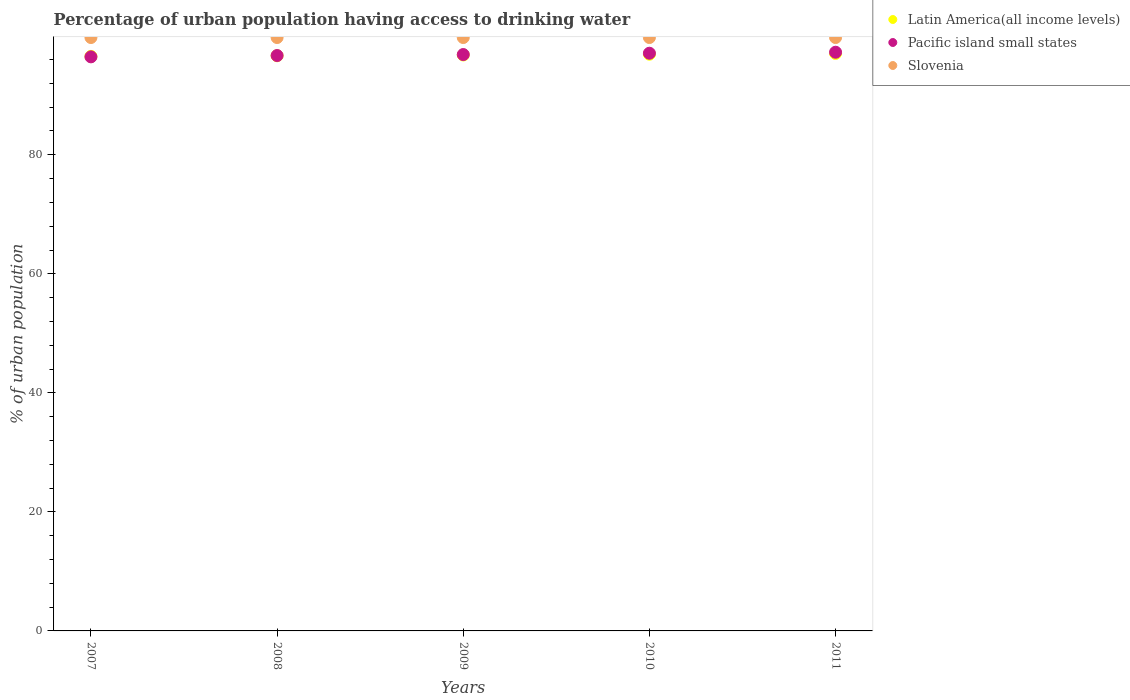How many different coloured dotlines are there?
Your response must be concise. 3. Is the number of dotlines equal to the number of legend labels?
Your answer should be compact. Yes. What is the percentage of urban population having access to drinking water in Slovenia in 2009?
Your answer should be compact. 99.7. Across all years, what is the maximum percentage of urban population having access to drinking water in Pacific island small states?
Make the answer very short. 97.23. Across all years, what is the minimum percentage of urban population having access to drinking water in Pacific island small states?
Offer a terse response. 96.45. In which year was the percentage of urban population having access to drinking water in Pacific island small states maximum?
Ensure brevity in your answer.  2011. What is the total percentage of urban population having access to drinking water in Pacific island small states in the graph?
Offer a terse response. 484.27. What is the difference between the percentage of urban population having access to drinking water in Pacific island small states in 2009 and that in 2010?
Provide a short and direct response. -0.22. What is the difference between the percentage of urban population having access to drinking water in Pacific island small states in 2010 and the percentage of urban population having access to drinking water in Slovenia in 2007?
Offer a very short reply. -2.63. What is the average percentage of urban population having access to drinking water in Slovenia per year?
Your response must be concise. 99.7. In the year 2007, what is the difference between the percentage of urban population having access to drinking water in Slovenia and percentage of urban population having access to drinking water in Pacific island small states?
Your response must be concise. 3.25. What is the ratio of the percentage of urban population having access to drinking water in Latin America(all income levels) in 2009 to that in 2011?
Keep it short and to the point. 1. Is the difference between the percentage of urban population having access to drinking water in Slovenia in 2008 and 2009 greater than the difference between the percentage of urban population having access to drinking water in Pacific island small states in 2008 and 2009?
Make the answer very short. Yes. What is the difference between the highest and the lowest percentage of urban population having access to drinking water in Pacific island small states?
Provide a succinct answer. 0.78. Is it the case that in every year, the sum of the percentage of urban population having access to drinking water in Slovenia and percentage of urban population having access to drinking water in Latin America(all income levels)  is greater than the percentage of urban population having access to drinking water in Pacific island small states?
Your answer should be very brief. Yes. Is the percentage of urban population having access to drinking water in Pacific island small states strictly greater than the percentage of urban population having access to drinking water in Slovenia over the years?
Provide a succinct answer. No. Is the percentage of urban population having access to drinking water in Pacific island small states strictly less than the percentage of urban population having access to drinking water in Latin America(all income levels) over the years?
Ensure brevity in your answer.  No. How many years are there in the graph?
Your answer should be compact. 5. What is the difference between two consecutive major ticks on the Y-axis?
Keep it short and to the point. 20. Are the values on the major ticks of Y-axis written in scientific E-notation?
Provide a short and direct response. No. Does the graph contain any zero values?
Ensure brevity in your answer.  No. Does the graph contain grids?
Keep it short and to the point. No. Where does the legend appear in the graph?
Give a very brief answer. Top right. How are the legend labels stacked?
Provide a short and direct response. Vertical. What is the title of the graph?
Offer a terse response. Percentage of urban population having access to drinking water. Does "Costa Rica" appear as one of the legend labels in the graph?
Keep it short and to the point. No. What is the label or title of the Y-axis?
Give a very brief answer. % of urban population. What is the % of urban population in Latin America(all income levels) in 2007?
Give a very brief answer. 96.54. What is the % of urban population in Pacific island small states in 2007?
Offer a terse response. 96.45. What is the % of urban population in Slovenia in 2007?
Your answer should be compact. 99.7. What is the % of urban population of Latin America(all income levels) in 2008?
Offer a terse response. 96.64. What is the % of urban population of Pacific island small states in 2008?
Provide a short and direct response. 96.68. What is the % of urban population of Slovenia in 2008?
Give a very brief answer. 99.7. What is the % of urban population in Latin America(all income levels) in 2009?
Your response must be concise. 96.77. What is the % of urban population of Pacific island small states in 2009?
Make the answer very short. 96.84. What is the % of urban population of Slovenia in 2009?
Offer a very short reply. 99.7. What is the % of urban population of Latin America(all income levels) in 2010?
Offer a terse response. 96.9. What is the % of urban population in Pacific island small states in 2010?
Offer a very short reply. 97.07. What is the % of urban population of Slovenia in 2010?
Ensure brevity in your answer.  99.7. What is the % of urban population in Latin America(all income levels) in 2011?
Provide a short and direct response. 97.03. What is the % of urban population in Pacific island small states in 2011?
Make the answer very short. 97.23. What is the % of urban population of Slovenia in 2011?
Offer a very short reply. 99.7. Across all years, what is the maximum % of urban population in Latin America(all income levels)?
Your answer should be compact. 97.03. Across all years, what is the maximum % of urban population of Pacific island small states?
Your answer should be very brief. 97.23. Across all years, what is the maximum % of urban population of Slovenia?
Give a very brief answer. 99.7. Across all years, what is the minimum % of urban population of Latin America(all income levels)?
Make the answer very short. 96.54. Across all years, what is the minimum % of urban population in Pacific island small states?
Your answer should be compact. 96.45. Across all years, what is the minimum % of urban population of Slovenia?
Keep it short and to the point. 99.7. What is the total % of urban population of Latin America(all income levels) in the graph?
Your answer should be compact. 483.87. What is the total % of urban population of Pacific island small states in the graph?
Your response must be concise. 484.27. What is the total % of urban population in Slovenia in the graph?
Keep it short and to the point. 498.5. What is the difference between the % of urban population in Latin America(all income levels) in 2007 and that in 2008?
Your answer should be very brief. -0.1. What is the difference between the % of urban population of Pacific island small states in 2007 and that in 2008?
Give a very brief answer. -0.22. What is the difference between the % of urban population in Latin America(all income levels) in 2007 and that in 2009?
Provide a short and direct response. -0.23. What is the difference between the % of urban population in Pacific island small states in 2007 and that in 2009?
Your answer should be very brief. -0.39. What is the difference between the % of urban population in Latin America(all income levels) in 2007 and that in 2010?
Ensure brevity in your answer.  -0.36. What is the difference between the % of urban population of Pacific island small states in 2007 and that in 2010?
Your response must be concise. -0.61. What is the difference between the % of urban population of Slovenia in 2007 and that in 2010?
Offer a very short reply. 0. What is the difference between the % of urban population of Latin America(all income levels) in 2007 and that in 2011?
Make the answer very short. -0.49. What is the difference between the % of urban population of Pacific island small states in 2007 and that in 2011?
Offer a very short reply. -0.78. What is the difference between the % of urban population of Latin America(all income levels) in 2008 and that in 2009?
Make the answer very short. -0.13. What is the difference between the % of urban population of Pacific island small states in 2008 and that in 2009?
Give a very brief answer. -0.16. What is the difference between the % of urban population of Latin America(all income levels) in 2008 and that in 2010?
Your answer should be very brief. -0.26. What is the difference between the % of urban population of Pacific island small states in 2008 and that in 2010?
Your answer should be compact. -0.39. What is the difference between the % of urban population of Slovenia in 2008 and that in 2010?
Your answer should be very brief. 0. What is the difference between the % of urban population in Latin America(all income levels) in 2008 and that in 2011?
Provide a short and direct response. -0.39. What is the difference between the % of urban population of Pacific island small states in 2008 and that in 2011?
Your answer should be compact. -0.56. What is the difference between the % of urban population of Latin America(all income levels) in 2009 and that in 2010?
Your answer should be very brief. -0.13. What is the difference between the % of urban population in Pacific island small states in 2009 and that in 2010?
Give a very brief answer. -0.22. What is the difference between the % of urban population of Slovenia in 2009 and that in 2010?
Your answer should be compact. 0. What is the difference between the % of urban population of Latin America(all income levels) in 2009 and that in 2011?
Your answer should be compact. -0.26. What is the difference between the % of urban population in Pacific island small states in 2009 and that in 2011?
Your answer should be compact. -0.39. What is the difference between the % of urban population in Latin America(all income levels) in 2010 and that in 2011?
Your response must be concise. -0.13. What is the difference between the % of urban population in Pacific island small states in 2010 and that in 2011?
Your answer should be compact. -0.17. What is the difference between the % of urban population of Slovenia in 2010 and that in 2011?
Your answer should be compact. 0. What is the difference between the % of urban population of Latin America(all income levels) in 2007 and the % of urban population of Pacific island small states in 2008?
Keep it short and to the point. -0.14. What is the difference between the % of urban population of Latin America(all income levels) in 2007 and the % of urban population of Slovenia in 2008?
Your answer should be very brief. -3.16. What is the difference between the % of urban population in Pacific island small states in 2007 and the % of urban population in Slovenia in 2008?
Your answer should be very brief. -3.25. What is the difference between the % of urban population in Latin America(all income levels) in 2007 and the % of urban population in Pacific island small states in 2009?
Your response must be concise. -0.3. What is the difference between the % of urban population in Latin America(all income levels) in 2007 and the % of urban population in Slovenia in 2009?
Offer a very short reply. -3.16. What is the difference between the % of urban population in Pacific island small states in 2007 and the % of urban population in Slovenia in 2009?
Your response must be concise. -3.25. What is the difference between the % of urban population of Latin America(all income levels) in 2007 and the % of urban population of Pacific island small states in 2010?
Keep it short and to the point. -0.53. What is the difference between the % of urban population of Latin America(all income levels) in 2007 and the % of urban population of Slovenia in 2010?
Your answer should be compact. -3.16. What is the difference between the % of urban population of Pacific island small states in 2007 and the % of urban population of Slovenia in 2010?
Offer a terse response. -3.25. What is the difference between the % of urban population of Latin America(all income levels) in 2007 and the % of urban population of Pacific island small states in 2011?
Make the answer very short. -0.7. What is the difference between the % of urban population of Latin America(all income levels) in 2007 and the % of urban population of Slovenia in 2011?
Ensure brevity in your answer.  -3.16. What is the difference between the % of urban population of Pacific island small states in 2007 and the % of urban population of Slovenia in 2011?
Give a very brief answer. -3.25. What is the difference between the % of urban population of Latin America(all income levels) in 2008 and the % of urban population of Pacific island small states in 2009?
Ensure brevity in your answer.  -0.21. What is the difference between the % of urban population of Latin America(all income levels) in 2008 and the % of urban population of Slovenia in 2009?
Keep it short and to the point. -3.06. What is the difference between the % of urban population in Pacific island small states in 2008 and the % of urban population in Slovenia in 2009?
Keep it short and to the point. -3.02. What is the difference between the % of urban population of Latin America(all income levels) in 2008 and the % of urban population of Pacific island small states in 2010?
Give a very brief answer. -0.43. What is the difference between the % of urban population of Latin America(all income levels) in 2008 and the % of urban population of Slovenia in 2010?
Keep it short and to the point. -3.06. What is the difference between the % of urban population in Pacific island small states in 2008 and the % of urban population in Slovenia in 2010?
Your answer should be very brief. -3.02. What is the difference between the % of urban population of Latin America(all income levels) in 2008 and the % of urban population of Pacific island small states in 2011?
Offer a terse response. -0.6. What is the difference between the % of urban population in Latin America(all income levels) in 2008 and the % of urban population in Slovenia in 2011?
Provide a succinct answer. -3.06. What is the difference between the % of urban population of Pacific island small states in 2008 and the % of urban population of Slovenia in 2011?
Provide a short and direct response. -3.02. What is the difference between the % of urban population of Latin America(all income levels) in 2009 and the % of urban population of Pacific island small states in 2010?
Your answer should be very brief. -0.3. What is the difference between the % of urban population of Latin America(all income levels) in 2009 and the % of urban population of Slovenia in 2010?
Give a very brief answer. -2.93. What is the difference between the % of urban population in Pacific island small states in 2009 and the % of urban population in Slovenia in 2010?
Your response must be concise. -2.86. What is the difference between the % of urban population in Latin America(all income levels) in 2009 and the % of urban population in Pacific island small states in 2011?
Your response must be concise. -0.46. What is the difference between the % of urban population of Latin America(all income levels) in 2009 and the % of urban population of Slovenia in 2011?
Ensure brevity in your answer.  -2.93. What is the difference between the % of urban population in Pacific island small states in 2009 and the % of urban population in Slovenia in 2011?
Ensure brevity in your answer.  -2.86. What is the difference between the % of urban population in Latin America(all income levels) in 2010 and the % of urban population in Pacific island small states in 2011?
Your response must be concise. -0.33. What is the difference between the % of urban population of Latin America(all income levels) in 2010 and the % of urban population of Slovenia in 2011?
Make the answer very short. -2.8. What is the difference between the % of urban population of Pacific island small states in 2010 and the % of urban population of Slovenia in 2011?
Offer a terse response. -2.63. What is the average % of urban population of Latin America(all income levels) per year?
Offer a very short reply. 96.77. What is the average % of urban population in Pacific island small states per year?
Offer a terse response. 96.85. What is the average % of urban population in Slovenia per year?
Keep it short and to the point. 99.7. In the year 2007, what is the difference between the % of urban population in Latin America(all income levels) and % of urban population in Pacific island small states?
Your answer should be compact. 0.08. In the year 2007, what is the difference between the % of urban population in Latin America(all income levels) and % of urban population in Slovenia?
Make the answer very short. -3.16. In the year 2007, what is the difference between the % of urban population in Pacific island small states and % of urban population in Slovenia?
Offer a terse response. -3.25. In the year 2008, what is the difference between the % of urban population of Latin America(all income levels) and % of urban population of Pacific island small states?
Offer a very short reply. -0.04. In the year 2008, what is the difference between the % of urban population of Latin America(all income levels) and % of urban population of Slovenia?
Ensure brevity in your answer.  -3.06. In the year 2008, what is the difference between the % of urban population in Pacific island small states and % of urban population in Slovenia?
Your response must be concise. -3.02. In the year 2009, what is the difference between the % of urban population of Latin America(all income levels) and % of urban population of Pacific island small states?
Your response must be concise. -0.07. In the year 2009, what is the difference between the % of urban population in Latin America(all income levels) and % of urban population in Slovenia?
Offer a very short reply. -2.93. In the year 2009, what is the difference between the % of urban population of Pacific island small states and % of urban population of Slovenia?
Offer a very short reply. -2.86. In the year 2010, what is the difference between the % of urban population in Latin America(all income levels) and % of urban population in Pacific island small states?
Your answer should be very brief. -0.17. In the year 2010, what is the difference between the % of urban population in Latin America(all income levels) and % of urban population in Slovenia?
Make the answer very short. -2.8. In the year 2010, what is the difference between the % of urban population in Pacific island small states and % of urban population in Slovenia?
Make the answer very short. -2.63. In the year 2011, what is the difference between the % of urban population of Latin America(all income levels) and % of urban population of Pacific island small states?
Your response must be concise. -0.2. In the year 2011, what is the difference between the % of urban population in Latin America(all income levels) and % of urban population in Slovenia?
Your answer should be compact. -2.67. In the year 2011, what is the difference between the % of urban population in Pacific island small states and % of urban population in Slovenia?
Your answer should be very brief. -2.47. What is the ratio of the % of urban population of Latin America(all income levels) in 2007 to that in 2008?
Give a very brief answer. 1. What is the ratio of the % of urban population of Latin America(all income levels) in 2007 to that in 2009?
Your answer should be very brief. 1. What is the ratio of the % of urban population of Slovenia in 2007 to that in 2009?
Your response must be concise. 1. What is the ratio of the % of urban population of Latin America(all income levels) in 2007 to that in 2010?
Provide a succinct answer. 1. What is the ratio of the % of urban population of Pacific island small states in 2007 to that in 2010?
Provide a short and direct response. 0.99. What is the ratio of the % of urban population of Slovenia in 2007 to that in 2010?
Your answer should be very brief. 1. What is the ratio of the % of urban population of Latin America(all income levels) in 2007 to that in 2011?
Keep it short and to the point. 0.99. What is the ratio of the % of urban population of Pacific island small states in 2007 to that in 2011?
Offer a very short reply. 0.99. What is the ratio of the % of urban population of Pacific island small states in 2008 to that in 2011?
Provide a short and direct response. 0.99. What is the ratio of the % of urban population of Slovenia in 2008 to that in 2011?
Provide a short and direct response. 1. What is the ratio of the % of urban population of Slovenia in 2009 to that in 2010?
Make the answer very short. 1. What is the ratio of the % of urban population of Latin America(all income levels) in 2009 to that in 2011?
Your answer should be compact. 1. What is the ratio of the % of urban population of Pacific island small states in 2009 to that in 2011?
Make the answer very short. 1. What is the ratio of the % of urban population of Latin America(all income levels) in 2010 to that in 2011?
Keep it short and to the point. 1. What is the ratio of the % of urban population of Pacific island small states in 2010 to that in 2011?
Give a very brief answer. 1. What is the ratio of the % of urban population of Slovenia in 2010 to that in 2011?
Offer a terse response. 1. What is the difference between the highest and the second highest % of urban population in Latin America(all income levels)?
Keep it short and to the point. 0.13. What is the difference between the highest and the second highest % of urban population in Pacific island small states?
Your response must be concise. 0.17. What is the difference between the highest and the second highest % of urban population of Slovenia?
Give a very brief answer. 0. What is the difference between the highest and the lowest % of urban population in Latin America(all income levels)?
Your answer should be very brief. 0.49. What is the difference between the highest and the lowest % of urban population in Pacific island small states?
Your answer should be very brief. 0.78. What is the difference between the highest and the lowest % of urban population in Slovenia?
Provide a succinct answer. 0. 